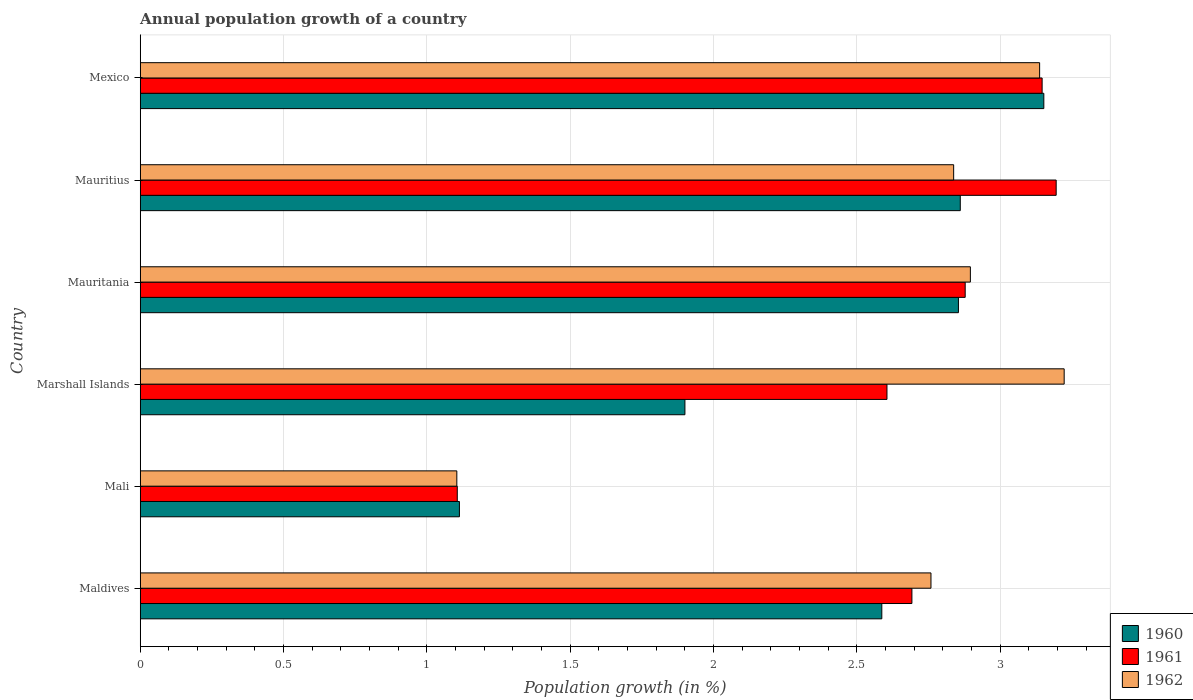How many different coloured bars are there?
Provide a succinct answer. 3. Are the number of bars per tick equal to the number of legend labels?
Your answer should be compact. Yes. How many bars are there on the 2nd tick from the top?
Your answer should be very brief. 3. How many bars are there on the 5th tick from the bottom?
Offer a very short reply. 3. In how many cases, is the number of bars for a given country not equal to the number of legend labels?
Your response must be concise. 0. What is the annual population growth in 1962 in Maldives?
Ensure brevity in your answer.  2.76. Across all countries, what is the maximum annual population growth in 1961?
Keep it short and to the point. 3.19. Across all countries, what is the minimum annual population growth in 1961?
Offer a very short reply. 1.11. In which country was the annual population growth in 1961 maximum?
Make the answer very short. Mauritius. In which country was the annual population growth in 1962 minimum?
Your answer should be compact. Mali. What is the total annual population growth in 1960 in the graph?
Provide a short and direct response. 14.47. What is the difference between the annual population growth in 1960 in Maldives and that in Marshall Islands?
Ensure brevity in your answer.  0.69. What is the difference between the annual population growth in 1962 in Mauritania and the annual population growth in 1961 in Mexico?
Your answer should be very brief. -0.25. What is the average annual population growth in 1962 per country?
Keep it short and to the point. 2.66. What is the difference between the annual population growth in 1961 and annual population growth in 1962 in Marshall Islands?
Offer a very short reply. -0.62. In how many countries, is the annual population growth in 1962 greater than 2.9 %?
Your answer should be very brief. 2. What is the ratio of the annual population growth in 1962 in Maldives to that in Mali?
Offer a very short reply. 2.5. What is the difference between the highest and the second highest annual population growth in 1961?
Give a very brief answer. 0.05. What is the difference between the highest and the lowest annual population growth in 1960?
Make the answer very short. 2.04. In how many countries, is the annual population growth in 1961 greater than the average annual population growth in 1961 taken over all countries?
Give a very brief answer. 5. What does the 1st bar from the bottom in Mexico represents?
Offer a very short reply. 1960. What is the difference between two consecutive major ticks on the X-axis?
Provide a succinct answer. 0.5. Does the graph contain any zero values?
Your response must be concise. No. Does the graph contain grids?
Provide a succinct answer. Yes. What is the title of the graph?
Your response must be concise. Annual population growth of a country. What is the label or title of the X-axis?
Your answer should be compact. Population growth (in %). What is the Population growth (in %) in 1960 in Maldives?
Make the answer very short. 2.59. What is the Population growth (in %) in 1961 in Maldives?
Your response must be concise. 2.69. What is the Population growth (in %) in 1962 in Maldives?
Your response must be concise. 2.76. What is the Population growth (in %) of 1960 in Mali?
Give a very brief answer. 1.11. What is the Population growth (in %) in 1961 in Mali?
Provide a succinct answer. 1.11. What is the Population growth (in %) in 1962 in Mali?
Provide a short and direct response. 1.1. What is the Population growth (in %) in 1960 in Marshall Islands?
Make the answer very short. 1.9. What is the Population growth (in %) in 1961 in Marshall Islands?
Provide a short and direct response. 2.6. What is the Population growth (in %) in 1962 in Marshall Islands?
Offer a very short reply. 3.22. What is the Population growth (in %) of 1960 in Mauritania?
Ensure brevity in your answer.  2.85. What is the Population growth (in %) in 1961 in Mauritania?
Keep it short and to the point. 2.88. What is the Population growth (in %) of 1962 in Mauritania?
Give a very brief answer. 2.9. What is the Population growth (in %) of 1960 in Mauritius?
Your response must be concise. 2.86. What is the Population growth (in %) in 1961 in Mauritius?
Offer a very short reply. 3.19. What is the Population growth (in %) in 1962 in Mauritius?
Provide a succinct answer. 2.84. What is the Population growth (in %) of 1960 in Mexico?
Make the answer very short. 3.15. What is the Population growth (in %) of 1961 in Mexico?
Your response must be concise. 3.15. What is the Population growth (in %) in 1962 in Mexico?
Make the answer very short. 3.14. Across all countries, what is the maximum Population growth (in %) in 1960?
Offer a terse response. 3.15. Across all countries, what is the maximum Population growth (in %) in 1961?
Provide a succinct answer. 3.19. Across all countries, what is the maximum Population growth (in %) in 1962?
Offer a terse response. 3.22. Across all countries, what is the minimum Population growth (in %) of 1960?
Offer a terse response. 1.11. Across all countries, what is the minimum Population growth (in %) in 1961?
Offer a terse response. 1.11. Across all countries, what is the minimum Population growth (in %) in 1962?
Give a very brief answer. 1.1. What is the total Population growth (in %) of 1960 in the graph?
Make the answer very short. 14.47. What is the total Population growth (in %) in 1961 in the graph?
Your answer should be compact. 15.62. What is the total Population growth (in %) of 1962 in the graph?
Make the answer very short. 15.96. What is the difference between the Population growth (in %) in 1960 in Maldives and that in Mali?
Ensure brevity in your answer.  1.47. What is the difference between the Population growth (in %) in 1961 in Maldives and that in Mali?
Your answer should be compact. 1.59. What is the difference between the Population growth (in %) of 1962 in Maldives and that in Mali?
Give a very brief answer. 1.65. What is the difference between the Population growth (in %) in 1960 in Maldives and that in Marshall Islands?
Keep it short and to the point. 0.69. What is the difference between the Population growth (in %) in 1961 in Maldives and that in Marshall Islands?
Provide a succinct answer. 0.09. What is the difference between the Population growth (in %) of 1962 in Maldives and that in Marshall Islands?
Your answer should be very brief. -0.46. What is the difference between the Population growth (in %) in 1960 in Maldives and that in Mauritania?
Offer a terse response. -0.27. What is the difference between the Population growth (in %) of 1961 in Maldives and that in Mauritania?
Give a very brief answer. -0.19. What is the difference between the Population growth (in %) in 1962 in Maldives and that in Mauritania?
Offer a terse response. -0.14. What is the difference between the Population growth (in %) in 1960 in Maldives and that in Mauritius?
Make the answer very short. -0.27. What is the difference between the Population growth (in %) of 1961 in Maldives and that in Mauritius?
Offer a very short reply. -0.5. What is the difference between the Population growth (in %) of 1962 in Maldives and that in Mauritius?
Your answer should be very brief. -0.08. What is the difference between the Population growth (in %) of 1960 in Maldives and that in Mexico?
Your answer should be very brief. -0.57. What is the difference between the Population growth (in %) of 1961 in Maldives and that in Mexico?
Give a very brief answer. -0.45. What is the difference between the Population growth (in %) in 1962 in Maldives and that in Mexico?
Provide a succinct answer. -0.38. What is the difference between the Population growth (in %) in 1960 in Mali and that in Marshall Islands?
Keep it short and to the point. -0.79. What is the difference between the Population growth (in %) of 1961 in Mali and that in Marshall Islands?
Provide a succinct answer. -1.5. What is the difference between the Population growth (in %) of 1962 in Mali and that in Marshall Islands?
Ensure brevity in your answer.  -2.12. What is the difference between the Population growth (in %) in 1960 in Mali and that in Mauritania?
Your response must be concise. -1.74. What is the difference between the Population growth (in %) of 1961 in Mali and that in Mauritania?
Ensure brevity in your answer.  -1.77. What is the difference between the Population growth (in %) in 1962 in Mali and that in Mauritania?
Give a very brief answer. -1.79. What is the difference between the Population growth (in %) of 1960 in Mali and that in Mauritius?
Offer a terse response. -1.75. What is the difference between the Population growth (in %) of 1961 in Mali and that in Mauritius?
Your answer should be very brief. -2.09. What is the difference between the Population growth (in %) in 1962 in Mali and that in Mauritius?
Ensure brevity in your answer.  -1.73. What is the difference between the Population growth (in %) of 1960 in Mali and that in Mexico?
Offer a very short reply. -2.04. What is the difference between the Population growth (in %) of 1961 in Mali and that in Mexico?
Your answer should be very brief. -2.04. What is the difference between the Population growth (in %) of 1962 in Mali and that in Mexico?
Your response must be concise. -2.03. What is the difference between the Population growth (in %) in 1960 in Marshall Islands and that in Mauritania?
Offer a terse response. -0.95. What is the difference between the Population growth (in %) in 1961 in Marshall Islands and that in Mauritania?
Make the answer very short. -0.27. What is the difference between the Population growth (in %) of 1962 in Marshall Islands and that in Mauritania?
Offer a very short reply. 0.33. What is the difference between the Population growth (in %) of 1960 in Marshall Islands and that in Mauritius?
Provide a short and direct response. -0.96. What is the difference between the Population growth (in %) of 1961 in Marshall Islands and that in Mauritius?
Your answer should be compact. -0.59. What is the difference between the Population growth (in %) of 1962 in Marshall Islands and that in Mauritius?
Your response must be concise. 0.39. What is the difference between the Population growth (in %) in 1960 in Marshall Islands and that in Mexico?
Give a very brief answer. -1.25. What is the difference between the Population growth (in %) in 1961 in Marshall Islands and that in Mexico?
Provide a succinct answer. -0.54. What is the difference between the Population growth (in %) in 1962 in Marshall Islands and that in Mexico?
Your response must be concise. 0.09. What is the difference between the Population growth (in %) in 1960 in Mauritania and that in Mauritius?
Offer a terse response. -0.01. What is the difference between the Population growth (in %) of 1961 in Mauritania and that in Mauritius?
Your answer should be very brief. -0.32. What is the difference between the Population growth (in %) of 1962 in Mauritania and that in Mauritius?
Your answer should be very brief. 0.06. What is the difference between the Population growth (in %) in 1960 in Mauritania and that in Mexico?
Your response must be concise. -0.3. What is the difference between the Population growth (in %) in 1961 in Mauritania and that in Mexico?
Provide a succinct answer. -0.27. What is the difference between the Population growth (in %) in 1962 in Mauritania and that in Mexico?
Your answer should be very brief. -0.24. What is the difference between the Population growth (in %) of 1960 in Mauritius and that in Mexico?
Your answer should be very brief. -0.29. What is the difference between the Population growth (in %) of 1961 in Mauritius and that in Mexico?
Your answer should be very brief. 0.05. What is the difference between the Population growth (in %) in 1962 in Mauritius and that in Mexico?
Your response must be concise. -0.3. What is the difference between the Population growth (in %) of 1960 in Maldives and the Population growth (in %) of 1961 in Mali?
Your answer should be compact. 1.48. What is the difference between the Population growth (in %) in 1960 in Maldives and the Population growth (in %) in 1962 in Mali?
Your response must be concise. 1.48. What is the difference between the Population growth (in %) of 1961 in Maldives and the Population growth (in %) of 1962 in Mali?
Offer a very short reply. 1.59. What is the difference between the Population growth (in %) of 1960 in Maldives and the Population growth (in %) of 1961 in Marshall Islands?
Provide a succinct answer. -0.02. What is the difference between the Population growth (in %) in 1960 in Maldives and the Population growth (in %) in 1962 in Marshall Islands?
Offer a very short reply. -0.64. What is the difference between the Population growth (in %) in 1961 in Maldives and the Population growth (in %) in 1962 in Marshall Islands?
Ensure brevity in your answer.  -0.53. What is the difference between the Population growth (in %) of 1960 in Maldives and the Population growth (in %) of 1961 in Mauritania?
Your answer should be compact. -0.29. What is the difference between the Population growth (in %) of 1960 in Maldives and the Population growth (in %) of 1962 in Mauritania?
Your answer should be compact. -0.31. What is the difference between the Population growth (in %) of 1961 in Maldives and the Population growth (in %) of 1962 in Mauritania?
Offer a terse response. -0.2. What is the difference between the Population growth (in %) in 1960 in Maldives and the Population growth (in %) in 1961 in Mauritius?
Give a very brief answer. -0.61. What is the difference between the Population growth (in %) of 1960 in Maldives and the Population growth (in %) of 1962 in Mauritius?
Your answer should be very brief. -0.25. What is the difference between the Population growth (in %) of 1961 in Maldives and the Population growth (in %) of 1962 in Mauritius?
Your response must be concise. -0.15. What is the difference between the Population growth (in %) of 1960 in Maldives and the Population growth (in %) of 1961 in Mexico?
Provide a succinct answer. -0.56. What is the difference between the Population growth (in %) of 1960 in Maldives and the Population growth (in %) of 1962 in Mexico?
Give a very brief answer. -0.55. What is the difference between the Population growth (in %) of 1961 in Maldives and the Population growth (in %) of 1962 in Mexico?
Make the answer very short. -0.45. What is the difference between the Population growth (in %) of 1960 in Mali and the Population growth (in %) of 1961 in Marshall Islands?
Offer a very short reply. -1.49. What is the difference between the Population growth (in %) of 1960 in Mali and the Population growth (in %) of 1962 in Marshall Islands?
Offer a very short reply. -2.11. What is the difference between the Population growth (in %) in 1961 in Mali and the Population growth (in %) in 1962 in Marshall Islands?
Your response must be concise. -2.12. What is the difference between the Population growth (in %) in 1960 in Mali and the Population growth (in %) in 1961 in Mauritania?
Provide a short and direct response. -1.76. What is the difference between the Population growth (in %) of 1960 in Mali and the Population growth (in %) of 1962 in Mauritania?
Give a very brief answer. -1.78. What is the difference between the Population growth (in %) in 1961 in Mali and the Population growth (in %) in 1962 in Mauritania?
Offer a terse response. -1.79. What is the difference between the Population growth (in %) of 1960 in Mali and the Population growth (in %) of 1961 in Mauritius?
Give a very brief answer. -2.08. What is the difference between the Population growth (in %) of 1960 in Mali and the Population growth (in %) of 1962 in Mauritius?
Ensure brevity in your answer.  -1.72. What is the difference between the Population growth (in %) of 1961 in Mali and the Population growth (in %) of 1962 in Mauritius?
Keep it short and to the point. -1.73. What is the difference between the Population growth (in %) in 1960 in Mali and the Population growth (in %) in 1961 in Mexico?
Your response must be concise. -2.03. What is the difference between the Population growth (in %) in 1960 in Mali and the Population growth (in %) in 1962 in Mexico?
Ensure brevity in your answer.  -2.02. What is the difference between the Population growth (in %) of 1961 in Mali and the Population growth (in %) of 1962 in Mexico?
Offer a terse response. -2.03. What is the difference between the Population growth (in %) in 1960 in Marshall Islands and the Population growth (in %) in 1961 in Mauritania?
Your answer should be compact. -0.98. What is the difference between the Population growth (in %) in 1960 in Marshall Islands and the Population growth (in %) in 1962 in Mauritania?
Give a very brief answer. -1. What is the difference between the Population growth (in %) in 1961 in Marshall Islands and the Population growth (in %) in 1962 in Mauritania?
Keep it short and to the point. -0.29. What is the difference between the Population growth (in %) of 1960 in Marshall Islands and the Population growth (in %) of 1961 in Mauritius?
Provide a short and direct response. -1.29. What is the difference between the Population growth (in %) in 1960 in Marshall Islands and the Population growth (in %) in 1962 in Mauritius?
Offer a very short reply. -0.94. What is the difference between the Population growth (in %) of 1961 in Marshall Islands and the Population growth (in %) of 1962 in Mauritius?
Your answer should be compact. -0.23. What is the difference between the Population growth (in %) in 1960 in Marshall Islands and the Population growth (in %) in 1961 in Mexico?
Make the answer very short. -1.25. What is the difference between the Population growth (in %) of 1960 in Marshall Islands and the Population growth (in %) of 1962 in Mexico?
Your response must be concise. -1.24. What is the difference between the Population growth (in %) of 1961 in Marshall Islands and the Population growth (in %) of 1962 in Mexico?
Give a very brief answer. -0.53. What is the difference between the Population growth (in %) in 1960 in Mauritania and the Population growth (in %) in 1961 in Mauritius?
Offer a very short reply. -0.34. What is the difference between the Population growth (in %) in 1960 in Mauritania and the Population growth (in %) in 1962 in Mauritius?
Make the answer very short. 0.02. What is the difference between the Population growth (in %) of 1961 in Mauritania and the Population growth (in %) of 1962 in Mauritius?
Keep it short and to the point. 0.04. What is the difference between the Population growth (in %) in 1960 in Mauritania and the Population growth (in %) in 1961 in Mexico?
Give a very brief answer. -0.29. What is the difference between the Population growth (in %) in 1960 in Mauritania and the Population growth (in %) in 1962 in Mexico?
Your response must be concise. -0.28. What is the difference between the Population growth (in %) in 1961 in Mauritania and the Population growth (in %) in 1962 in Mexico?
Give a very brief answer. -0.26. What is the difference between the Population growth (in %) in 1960 in Mauritius and the Population growth (in %) in 1961 in Mexico?
Offer a terse response. -0.29. What is the difference between the Population growth (in %) of 1960 in Mauritius and the Population growth (in %) of 1962 in Mexico?
Ensure brevity in your answer.  -0.28. What is the difference between the Population growth (in %) of 1961 in Mauritius and the Population growth (in %) of 1962 in Mexico?
Offer a terse response. 0.06. What is the average Population growth (in %) of 1960 per country?
Provide a short and direct response. 2.41. What is the average Population growth (in %) in 1961 per country?
Provide a succinct answer. 2.6. What is the average Population growth (in %) in 1962 per country?
Make the answer very short. 2.66. What is the difference between the Population growth (in %) in 1960 and Population growth (in %) in 1961 in Maldives?
Give a very brief answer. -0.1. What is the difference between the Population growth (in %) in 1960 and Population growth (in %) in 1962 in Maldives?
Provide a succinct answer. -0.17. What is the difference between the Population growth (in %) in 1961 and Population growth (in %) in 1962 in Maldives?
Your answer should be compact. -0.07. What is the difference between the Population growth (in %) of 1960 and Population growth (in %) of 1961 in Mali?
Give a very brief answer. 0.01. What is the difference between the Population growth (in %) in 1960 and Population growth (in %) in 1962 in Mali?
Provide a short and direct response. 0.01. What is the difference between the Population growth (in %) in 1961 and Population growth (in %) in 1962 in Mali?
Your answer should be very brief. 0. What is the difference between the Population growth (in %) in 1960 and Population growth (in %) in 1961 in Marshall Islands?
Ensure brevity in your answer.  -0.7. What is the difference between the Population growth (in %) of 1960 and Population growth (in %) of 1962 in Marshall Islands?
Your response must be concise. -1.32. What is the difference between the Population growth (in %) of 1961 and Population growth (in %) of 1962 in Marshall Islands?
Your response must be concise. -0.62. What is the difference between the Population growth (in %) of 1960 and Population growth (in %) of 1961 in Mauritania?
Your answer should be very brief. -0.02. What is the difference between the Population growth (in %) in 1960 and Population growth (in %) in 1962 in Mauritania?
Your answer should be very brief. -0.04. What is the difference between the Population growth (in %) of 1961 and Population growth (in %) of 1962 in Mauritania?
Make the answer very short. -0.02. What is the difference between the Population growth (in %) of 1960 and Population growth (in %) of 1961 in Mauritius?
Provide a succinct answer. -0.33. What is the difference between the Population growth (in %) of 1960 and Population growth (in %) of 1962 in Mauritius?
Provide a succinct answer. 0.02. What is the difference between the Population growth (in %) in 1961 and Population growth (in %) in 1962 in Mauritius?
Provide a short and direct response. 0.36. What is the difference between the Population growth (in %) in 1960 and Population growth (in %) in 1961 in Mexico?
Provide a short and direct response. 0.01. What is the difference between the Population growth (in %) in 1960 and Population growth (in %) in 1962 in Mexico?
Offer a terse response. 0.01. What is the difference between the Population growth (in %) of 1961 and Population growth (in %) of 1962 in Mexico?
Your answer should be very brief. 0.01. What is the ratio of the Population growth (in %) of 1960 in Maldives to that in Mali?
Your answer should be very brief. 2.32. What is the ratio of the Population growth (in %) in 1961 in Maldives to that in Mali?
Make the answer very short. 2.43. What is the ratio of the Population growth (in %) in 1962 in Maldives to that in Mali?
Ensure brevity in your answer.  2.5. What is the ratio of the Population growth (in %) in 1960 in Maldives to that in Marshall Islands?
Give a very brief answer. 1.36. What is the ratio of the Population growth (in %) of 1961 in Maldives to that in Marshall Islands?
Your response must be concise. 1.03. What is the ratio of the Population growth (in %) of 1962 in Maldives to that in Marshall Islands?
Your answer should be compact. 0.86. What is the ratio of the Population growth (in %) of 1960 in Maldives to that in Mauritania?
Provide a short and direct response. 0.91. What is the ratio of the Population growth (in %) in 1961 in Maldives to that in Mauritania?
Your answer should be compact. 0.94. What is the ratio of the Population growth (in %) in 1962 in Maldives to that in Mauritania?
Your answer should be very brief. 0.95. What is the ratio of the Population growth (in %) in 1960 in Maldives to that in Mauritius?
Provide a short and direct response. 0.9. What is the ratio of the Population growth (in %) in 1961 in Maldives to that in Mauritius?
Keep it short and to the point. 0.84. What is the ratio of the Population growth (in %) in 1962 in Maldives to that in Mauritius?
Keep it short and to the point. 0.97. What is the ratio of the Population growth (in %) of 1960 in Maldives to that in Mexico?
Give a very brief answer. 0.82. What is the ratio of the Population growth (in %) of 1961 in Maldives to that in Mexico?
Your response must be concise. 0.86. What is the ratio of the Population growth (in %) of 1962 in Maldives to that in Mexico?
Your answer should be compact. 0.88. What is the ratio of the Population growth (in %) of 1960 in Mali to that in Marshall Islands?
Your answer should be compact. 0.59. What is the ratio of the Population growth (in %) of 1961 in Mali to that in Marshall Islands?
Give a very brief answer. 0.42. What is the ratio of the Population growth (in %) of 1962 in Mali to that in Marshall Islands?
Your answer should be compact. 0.34. What is the ratio of the Population growth (in %) in 1960 in Mali to that in Mauritania?
Your answer should be very brief. 0.39. What is the ratio of the Population growth (in %) of 1961 in Mali to that in Mauritania?
Ensure brevity in your answer.  0.38. What is the ratio of the Population growth (in %) in 1962 in Mali to that in Mauritania?
Your answer should be compact. 0.38. What is the ratio of the Population growth (in %) of 1960 in Mali to that in Mauritius?
Make the answer very short. 0.39. What is the ratio of the Population growth (in %) in 1961 in Mali to that in Mauritius?
Give a very brief answer. 0.35. What is the ratio of the Population growth (in %) of 1962 in Mali to that in Mauritius?
Give a very brief answer. 0.39. What is the ratio of the Population growth (in %) in 1960 in Mali to that in Mexico?
Keep it short and to the point. 0.35. What is the ratio of the Population growth (in %) in 1961 in Mali to that in Mexico?
Your answer should be compact. 0.35. What is the ratio of the Population growth (in %) of 1962 in Mali to that in Mexico?
Provide a short and direct response. 0.35. What is the ratio of the Population growth (in %) of 1960 in Marshall Islands to that in Mauritania?
Make the answer very short. 0.67. What is the ratio of the Population growth (in %) in 1961 in Marshall Islands to that in Mauritania?
Your response must be concise. 0.91. What is the ratio of the Population growth (in %) of 1962 in Marshall Islands to that in Mauritania?
Offer a terse response. 1.11. What is the ratio of the Population growth (in %) in 1960 in Marshall Islands to that in Mauritius?
Offer a very short reply. 0.66. What is the ratio of the Population growth (in %) of 1961 in Marshall Islands to that in Mauritius?
Your answer should be very brief. 0.82. What is the ratio of the Population growth (in %) in 1962 in Marshall Islands to that in Mauritius?
Provide a succinct answer. 1.14. What is the ratio of the Population growth (in %) of 1960 in Marshall Islands to that in Mexico?
Provide a succinct answer. 0.6. What is the ratio of the Population growth (in %) of 1961 in Marshall Islands to that in Mexico?
Give a very brief answer. 0.83. What is the ratio of the Population growth (in %) in 1962 in Marshall Islands to that in Mexico?
Provide a succinct answer. 1.03. What is the ratio of the Population growth (in %) in 1961 in Mauritania to that in Mauritius?
Your answer should be very brief. 0.9. What is the ratio of the Population growth (in %) of 1962 in Mauritania to that in Mauritius?
Give a very brief answer. 1.02. What is the ratio of the Population growth (in %) in 1960 in Mauritania to that in Mexico?
Provide a succinct answer. 0.91. What is the ratio of the Population growth (in %) of 1961 in Mauritania to that in Mexico?
Keep it short and to the point. 0.91. What is the ratio of the Population growth (in %) of 1962 in Mauritania to that in Mexico?
Keep it short and to the point. 0.92. What is the ratio of the Population growth (in %) of 1960 in Mauritius to that in Mexico?
Make the answer very short. 0.91. What is the ratio of the Population growth (in %) in 1961 in Mauritius to that in Mexico?
Provide a short and direct response. 1.02. What is the ratio of the Population growth (in %) of 1962 in Mauritius to that in Mexico?
Give a very brief answer. 0.9. What is the difference between the highest and the second highest Population growth (in %) in 1960?
Make the answer very short. 0.29. What is the difference between the highest and the second highest Population growth (in %) of 1961?
Your answer should be very brief. 0.05. What is the difference between the highest and the second highest Population growth (in %) in 1962?
Offer a terse response. 0.09. What is the difference between the highest and the lowest Population growth (in %) in 1960?
Ensure brevity in your answer.  2.04. What is the difference between the highest and the lowest Population growth (in %) of 1961?
Ensure brevity in your answer.  2.09. What is the difference between the highest and the lowest Population growth (in %) of 1962?
Ensure brevity in your answer.  2.12. 